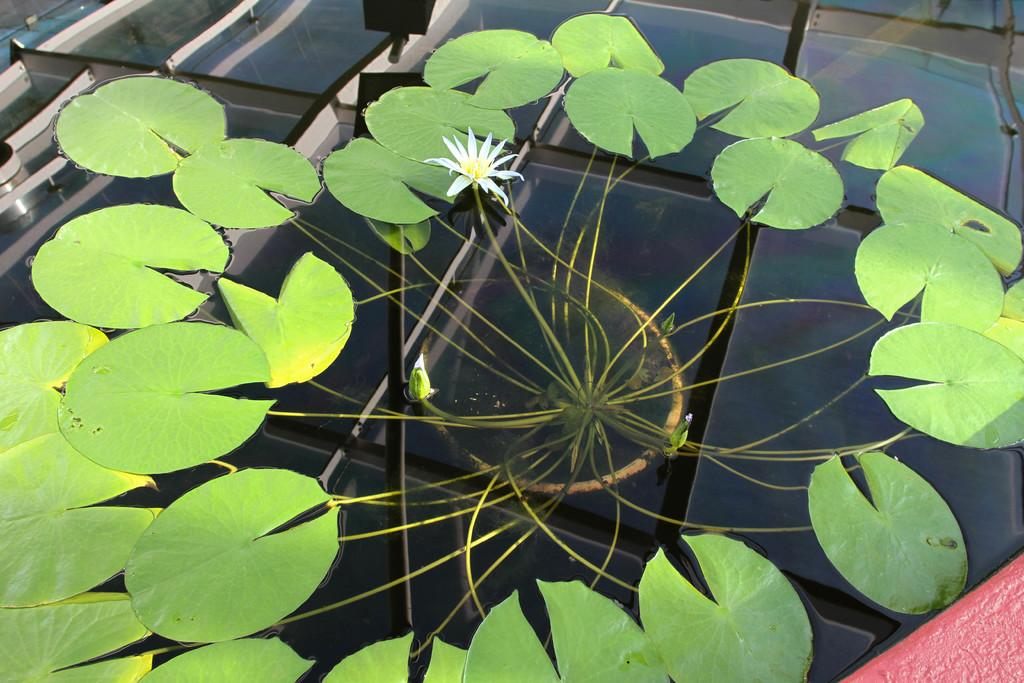What is the main object in the image? There is a pole in the image. What can be seen in the center of the image? There is a flower in the center of the image. What type of vegetation is visible on the water in the image? There are leaves visible on the water in the image. How many oranges are hanging from the pole in the image? There are no oranges present in the image. What type of boundary can be seen surrounding the flower in the image? There is no boundary surrounding the flower in the image. Is there a hill visible in the background of the image? There is no hill visible in the image. 